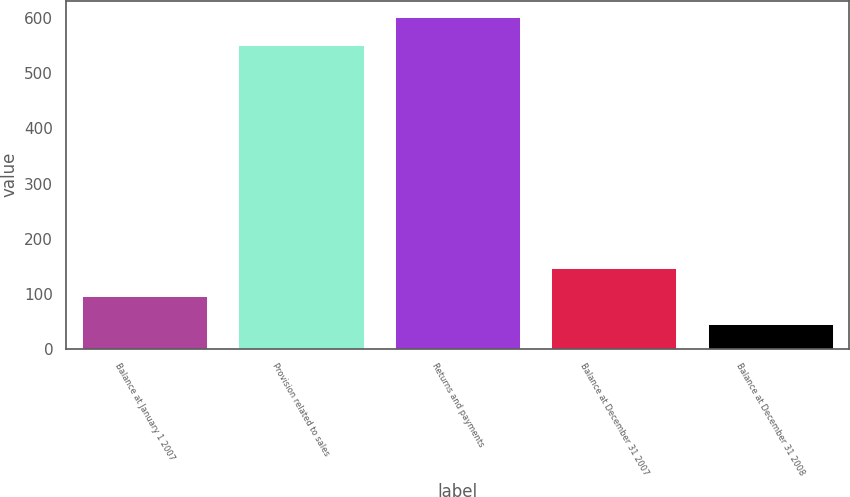<chart> <loc_0><loc_0><loc_500><loc_500><bar_chart><fcel>Balance at January 1 2007<fcel>Provision related to sales<fcel>Returns and payments<fcel>Balance at December 31 2007<fcel>Balance at December 31 2008<nl><fcel>95.6<fcel>551<fcel>601.6<fcel>146.2<fcel>45<nl></chart> 